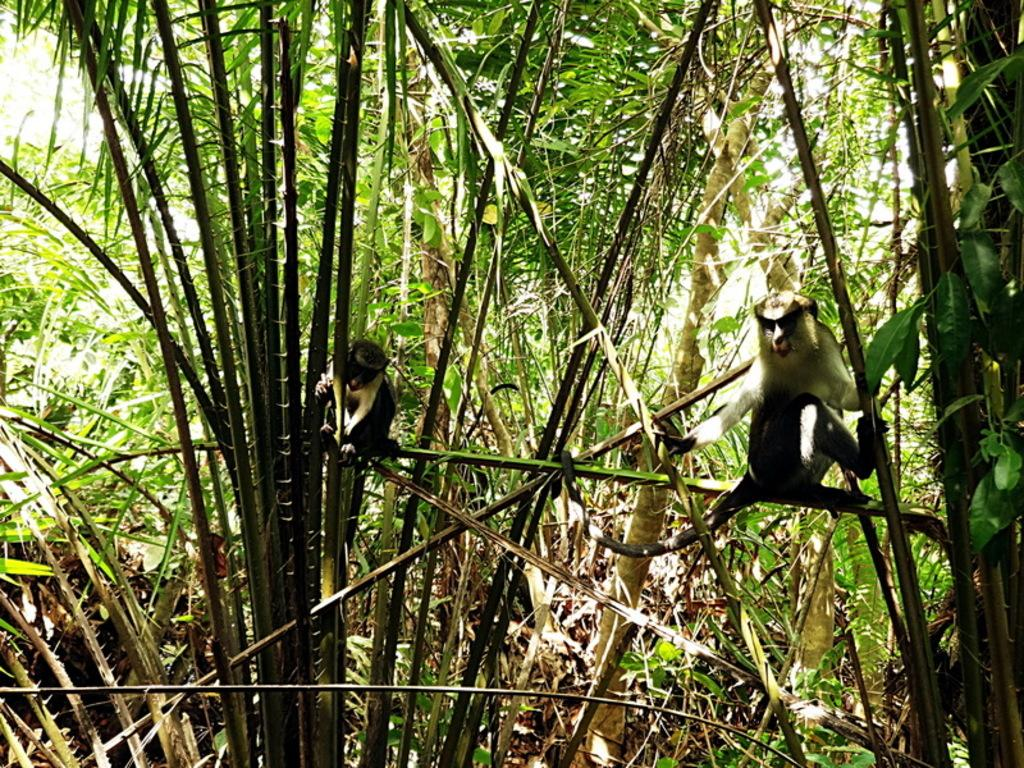What type of vegetation can be seen in the image? There are trees in the image. Are there any animals present in the image? Yes, there are two monkeys in the image. How many friends does the worm have in the image? There is no worm present in the image, so it is not possible to determine how many friends the worm might have. 